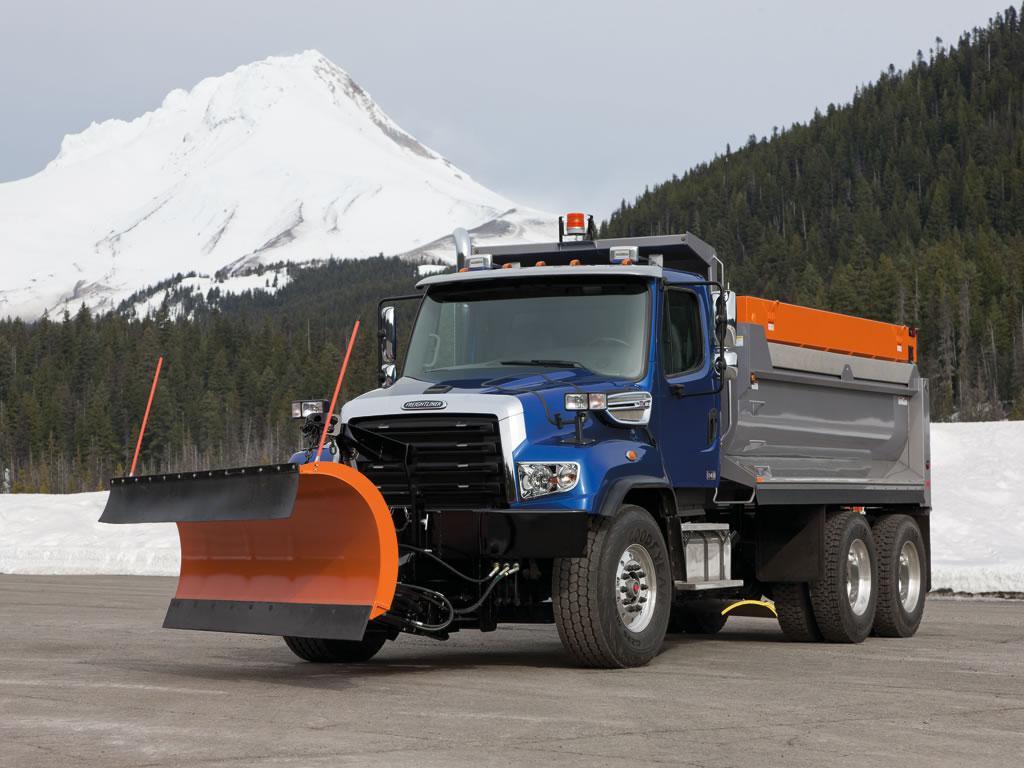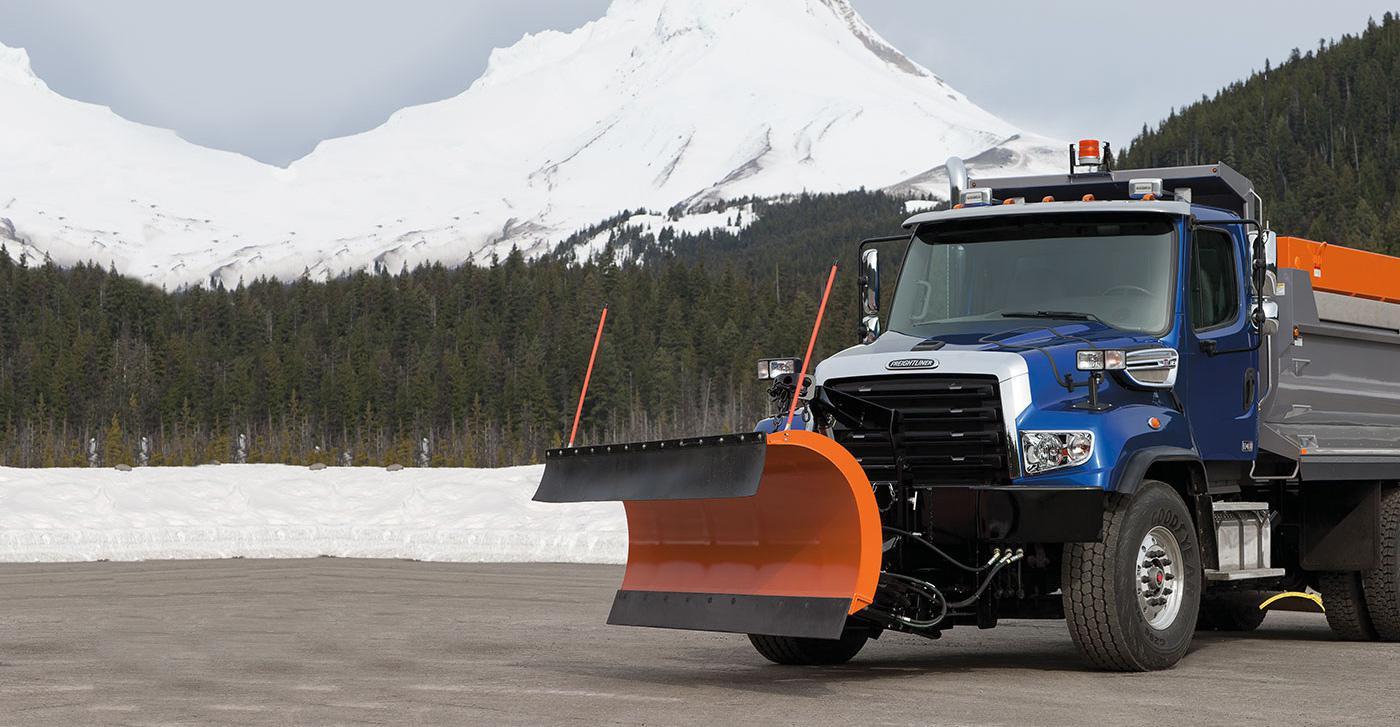The first image is the image on the left, the second image is the image on the right. Evaluate the accuracy of this statement regarding the images: "There is at least one blue truck in the images.". Is it true? Answer yes or no. Yes. 